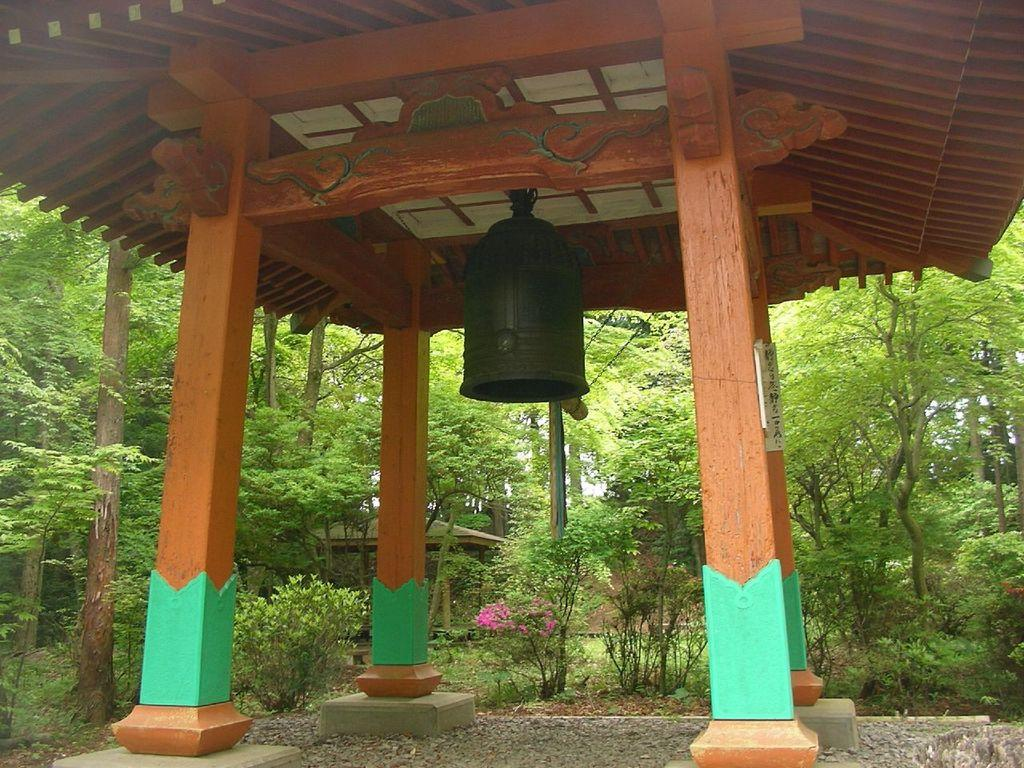What object is hanging from the wooden roof top in the image? There is a bell hanging from the wooden roof top in the image. How is the wooden roof top supported? The wooden roof top is supported by wooden pillars. What can be seen in the background of the image? There are plants, trees, and a wooden shed in the background of the image. What color is the chalk used to draw on the bell in the image? There is no chalk or drawing on the bell in the image. How does the alarm function in the image? There is no alarm present in the image; it only features a bell hanging from a wooden roof top. 